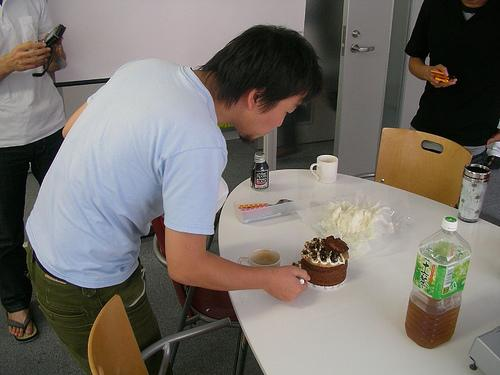About how much liquid is in the bottle with the green label? third 